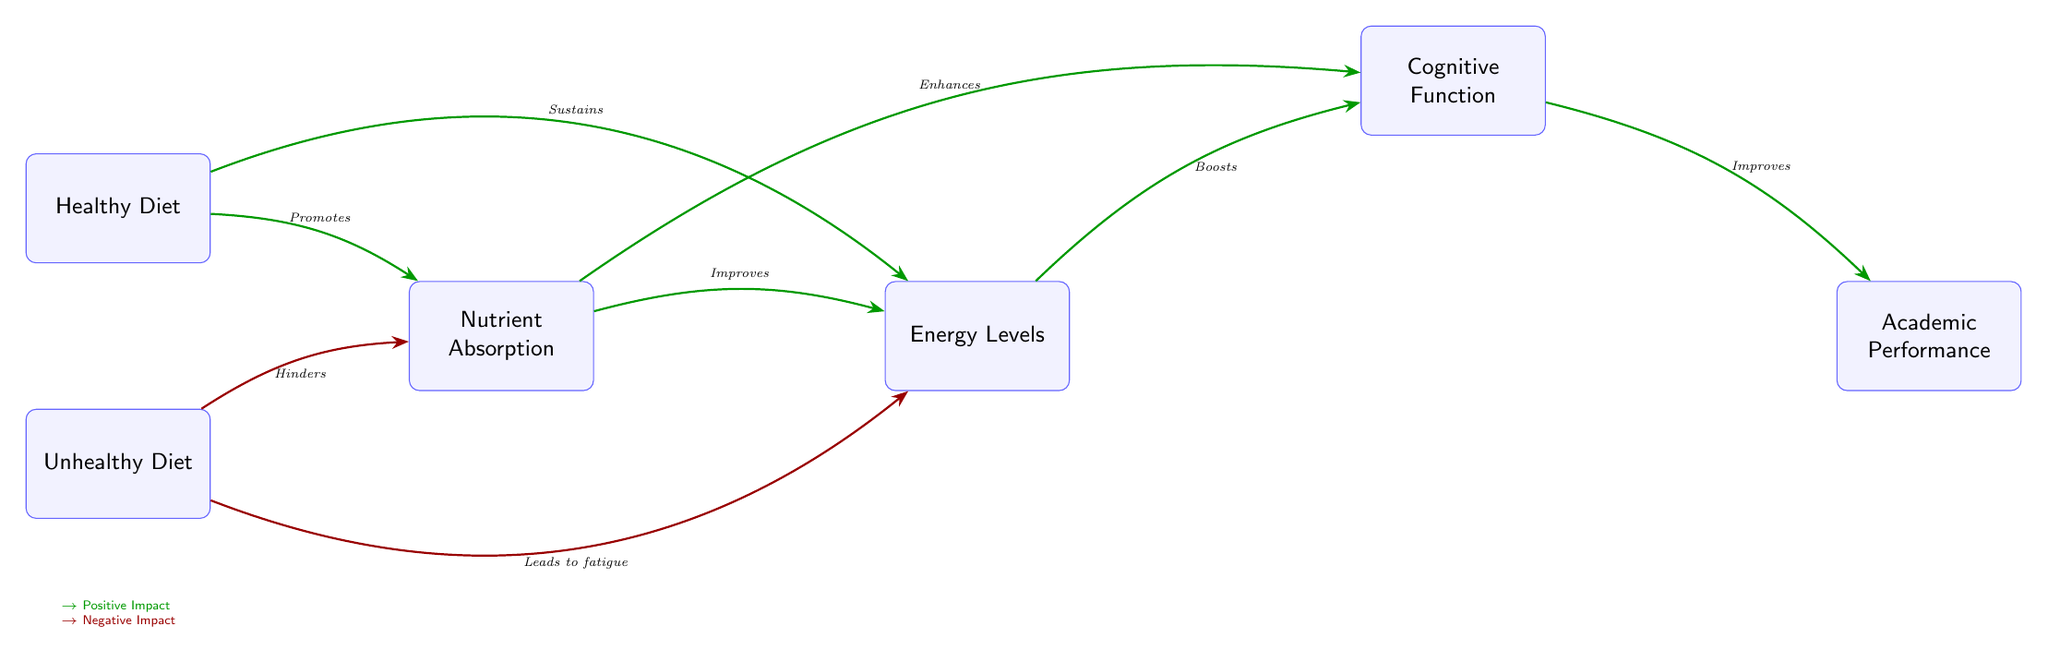What are the two types of diets represented in the diagram? The diagram displays two types of diets: "Healthy Diet" and "Unhealthy Diet". These are the main categories shown in the first two nodes of the diagram.
Answer: Healthy Diet, Unhealthy Diet Which node represents "Nutrient Absorption"? "Nutrient Absorption" is the third node in the flow of the diagram, and it's positioned to the right of both "Healthy Diet" and "Unhealthy Diet".
Answer: Nutrient Absorption How does a healthy diet affect nutrient absorption? A healthy diet is shown to have a positive impact on nutrient absorption, indicated by an arrow labeled "Promotes" pointing from "Healthy Diet" to "Nutrient Absorption".
Answer: Promotes What effect does an unhealthy diet have on energy levels? The diagram indicates that an unhealthy diet has a negative impact on energy levels, represented by an arrow labeled "Leads to fatigue" pointing from "Unhealthy Diet" to "Energy Levels".
Answer: Leads to fatigue What is the relationship between "Cognitive Function" and "Academic Performance"? The diagram shows a direct positive relationship where "Cognitive Function" improves "Academic Performance", as indicated by the arrow labeled "Improves" pointing from "Cognitive Function" to "Academic Performance".
Answer: Improves What impact does nutrient absorption have on energy levels? The diagram shows that nutrient absorption has a positive effect on energy levels, indicated by the arrow labeled "Improves" pointing from "Nutrient Absorption" to "Energy Levels".
Answer: Improves Which node could be considered the final outcome of the chain? The final outcome of the chain, as depicted in the diagram, is "Academic Performance", which represents the end result influenced by previous nodes.
Answer: Academic Performance How many positive impacts are shown in the diagram? The diagram illustrates four positive impacts, corresponding to the arrows that lead from "Healthy Diet" to "Nutrient Absorption", "Healthy Diet" to "Energy Levels", "Nutrient Absorption" to "Energy Levels", and "Cognitive Function" to "Academic Performance".
Answer: Four How does energy levels affect cognitive function? The diagram indicates a positive impact from energy levels to cognitive function, as shown by an arrow labeled "Boosts" pointing from "Energy Levels" to "Cognitive Function".
Answer: Boosts 